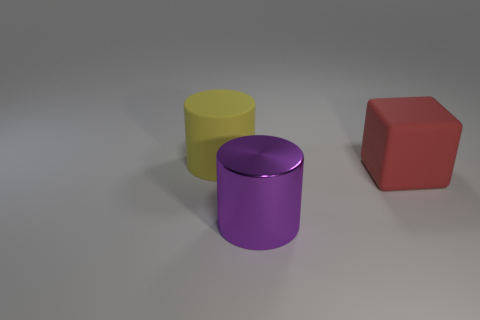Is the shape of the red matte object the same as the yellow object?
Your response must be concise. No. Are there any big yellow matte objects of the same shape as the red rubber object?
Keep it short and to the point. No. There is a matte object that is to the left of the big matte object that is right of the big purple metal cylinder; what is its shape?
Offer a very short reply. Cylinder. The big matte thing left of the big purple thing is what color?
Provide a succinct answer. Yellow. What is the size of the other object that is made of the same material as the yellow object?
Give a very brief answer. Large. What is the size of the other object that is the same shape as the yellow matte thing?
Provide a succinct answer. Large. Is there a blue object?
Offer a terse response. No. What number of objects are cylinders that are behind the purple metal object or yellow cylinders?
Your answer should be compact. 1. There is a yellow thing that is the same size as the matte block; what material is it?
Ensure brevity in your answer.  Rubber. What is the color of the large object that is on the left side of the big cylinder that is to the right of the big yellow matte object?
Make the answer very short. Yellow. 